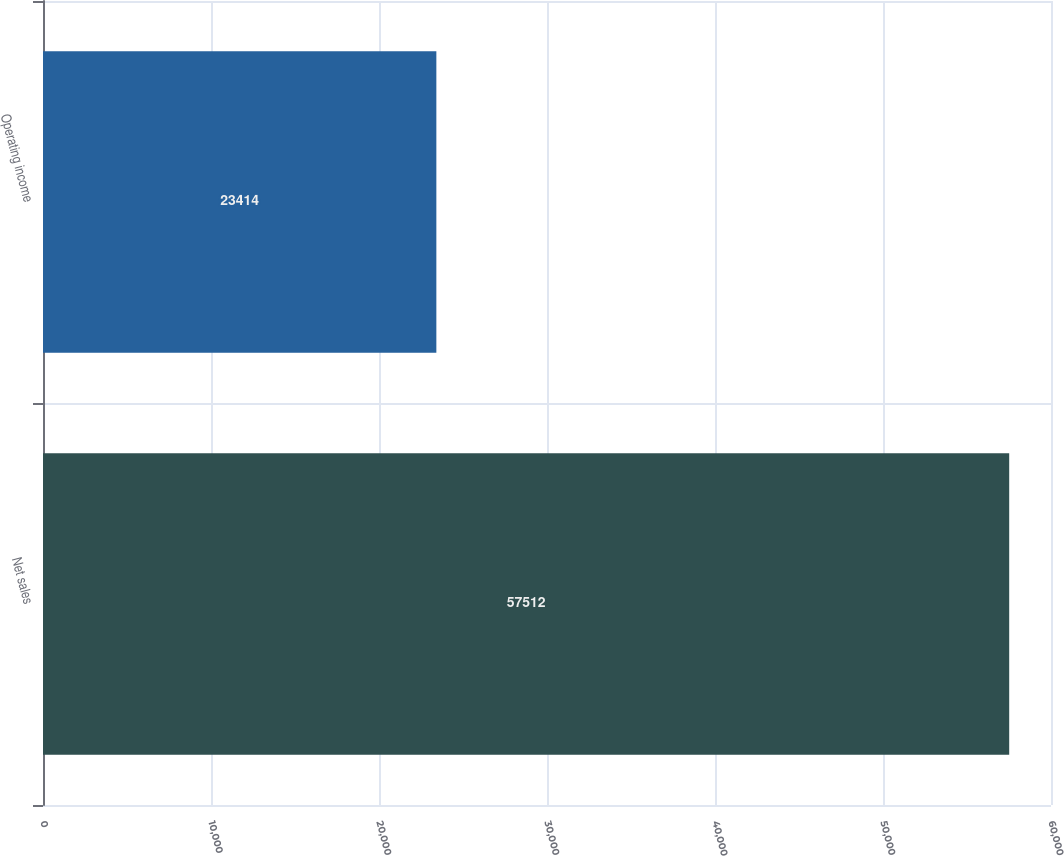Convert chart to OTSL. <chart><loc_0><loc_0><loc_500><loc_500><bar_chart><fcel>Net sales<fcel>Operating income<nl><fcel>57512<fcel>23414<nl></chart> 